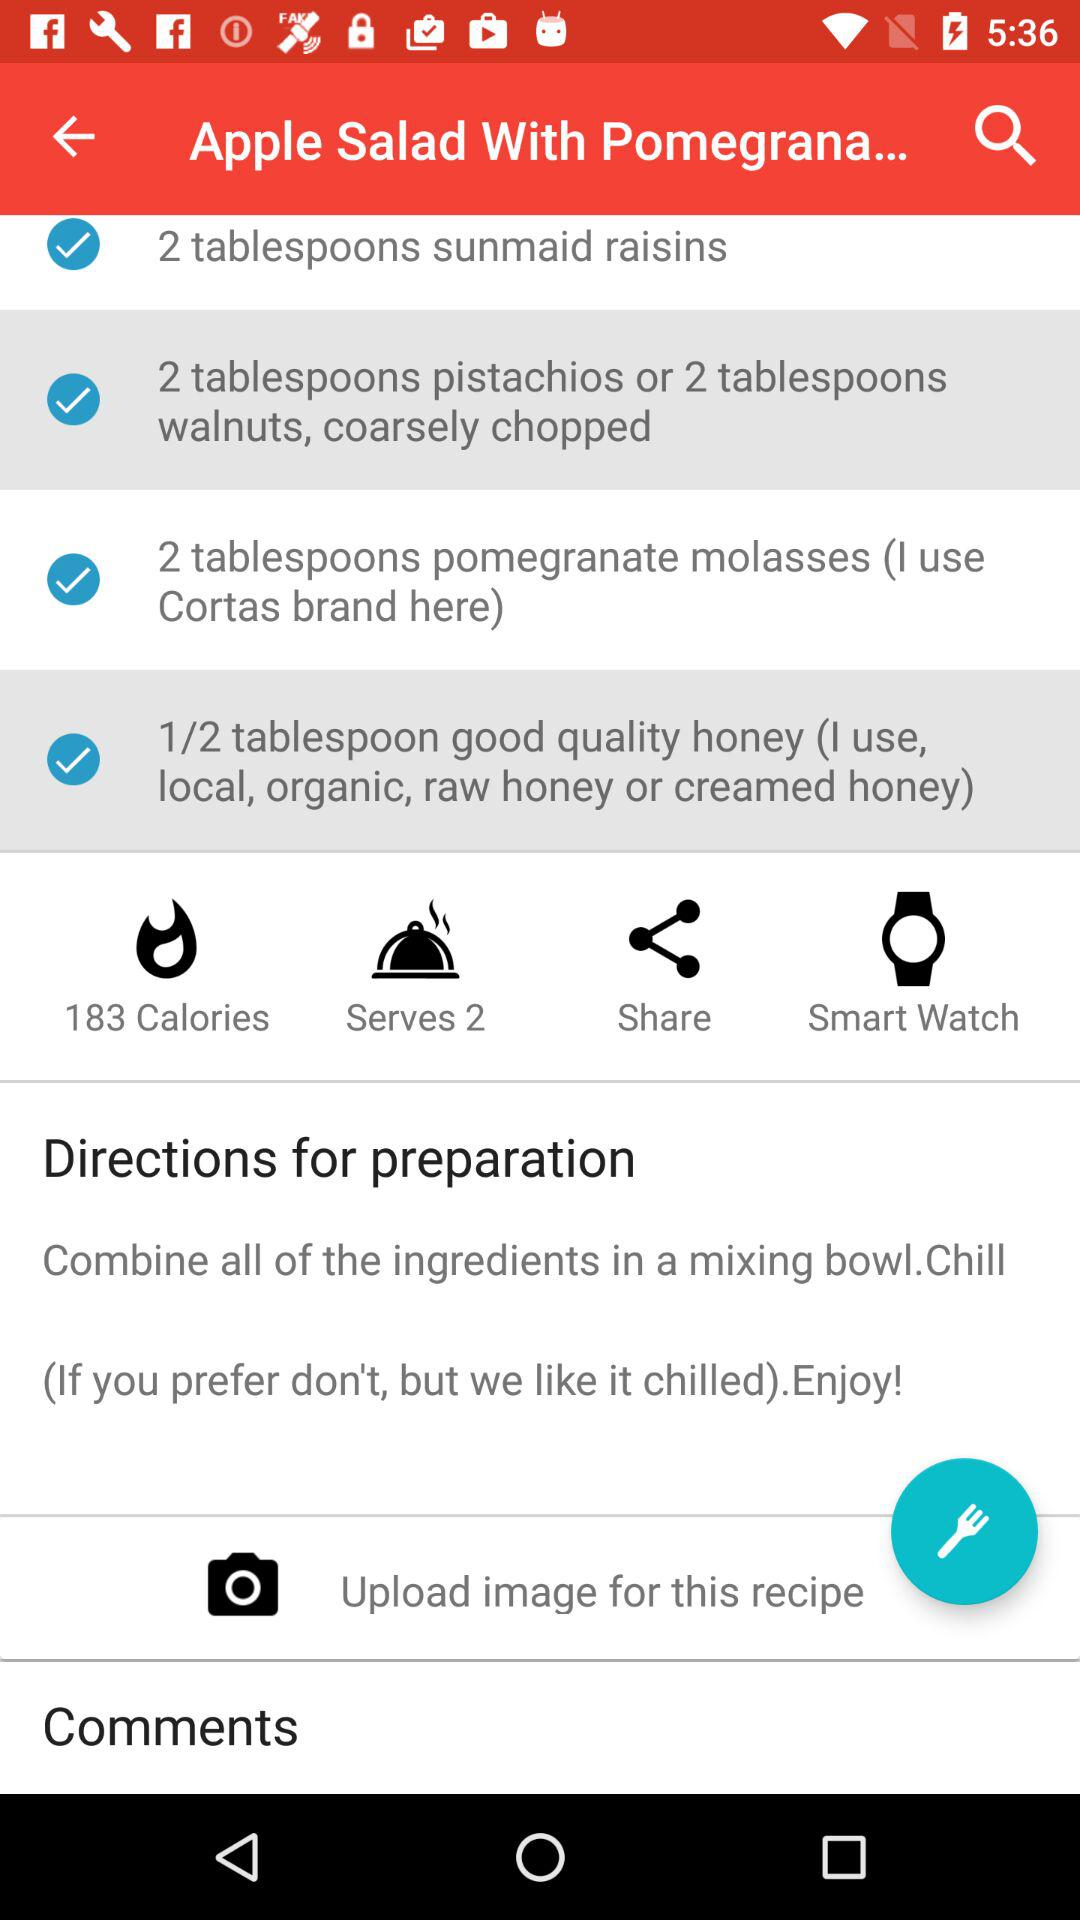What is the count of calories? The count of calories is 183. 